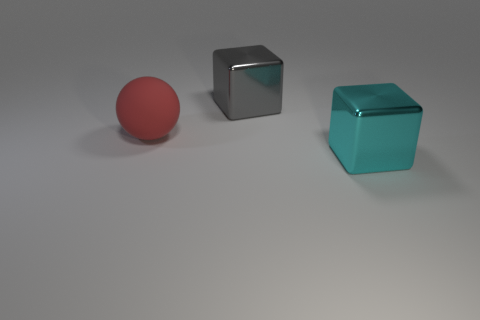Are there any other things that are the same shape as the big rubber object?
Your answer should be very brief. No. What color is the large shiny cube on the left side of the metallic cube in front of the large matte sphere?
Ensure brevity in your answer.  Gray. What is the thing that is on the left side of the big cube behind the large block that is in front of the large gray shiny block made of?
Make the answer very short. Rubber. There is a object that is on the left side of the gray metallic thing; what is it made of?
Provide a short and direct response. Rubber. Are there more big blocks than red rubber objects?
Make the answer very short. Yes. How many objects are big objects on the right side of the big red ball or big gray blocks?
Offer a very short reply. 2. There is a block that is in front of the red sphere; how many cyan metallic things are behind it?
Provide a succinct answer. 0. Do the cube that is behind the large cyan metal thing and the ball have the same color?
Keep it short and to the point. No. What number of objects are gray metallic cubes behind the large cyan object or large blocks behind the big red matte ball?
Keep it short and to the point. 1. What is the shape of the shiny object right of the object that is behind the large red ball?
Offer a terse response. Cube. 